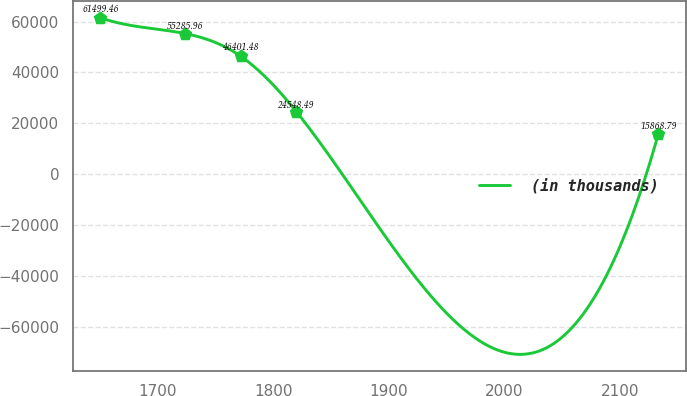<chart> <loc_0><loc_0><loc_500><loc_500><line_chart><ecel><fcel>(in thousands)<nl><fcel>1650.57<fcel>61499.5<nl><fcel>1723.51<fcel>55286<nl><fcel>1771.78<fcel>46401.5<nl><fcel>1820.05<fcel>24548.5<nl><fcel>2133.26<fcel>15868.8<nl></chart> 